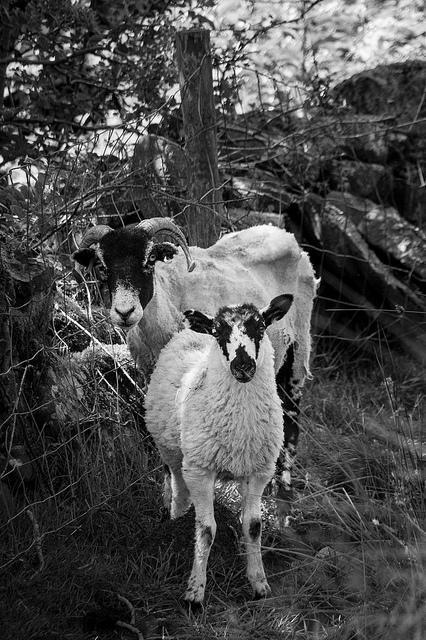How many sheep have black faces?
Give a very brief answer. 2. How many sheep in this photo have mostly white faces with a bit of black markings?
Give a very brief answer. 1. How many sheep are there?
Give a very brief answer. 2. 